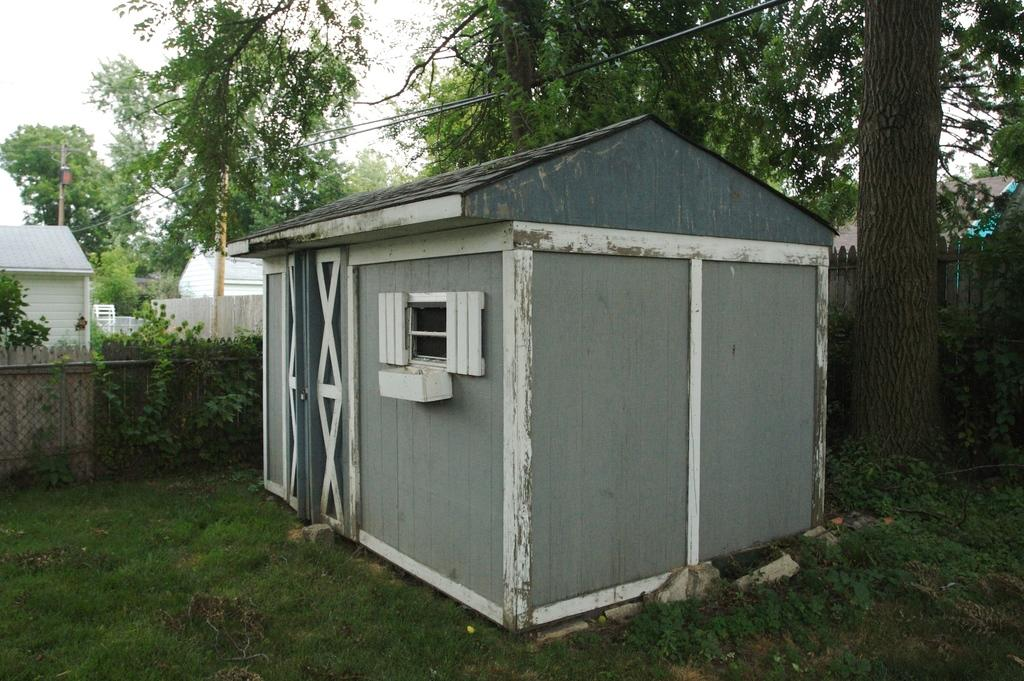What type of structure is in the image? There is a small wooden house in the image. What features does the house have? The house has a door and a window. What type of vegetation is present in the image? There is grass in the image, as well as trees with branches and leaves. What type of barrier is visible in the image? There is a wooden fence in the image. What direction is the cow facing in the image? There is no cow present in the image. What organization is responsible for maintaining the wooden fence in the image? The image does not provide information about the organization responsible for maintaining the wooden fence. 